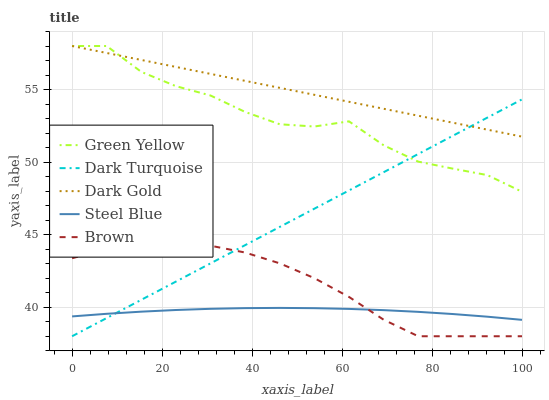Does Steel Blue have the minimum area under the curve?
Answer yes or no. Yes. Does Dark Gold have the maximum area under the curve?
Answer yes or no. Yes. Does Green Yellow have the minimum area under the curve?
Answer yes or no. No. Does Green Yellow have the maximum area under the curve?
Answer yes or no. No. Is Dark Gold the smoothest?
Answer yes or no. Yes. Is Green Yellow the roughest?
Answer yes or no. Yes. Is Steel Blue the smoothest?
Answer yes or no. No. Is Steel Blue the roughest?
Answer yes or no. No. Does Green Yellow have the lowest value?
Answer yes or no. No. Does Steel Blue have the highest value?
Answer yes or no. No. Is Brown less than Green Yellow?
Answer yes or no. Yes. Is Green Yellow greater than Brown?
Answer yes or no. Yes. Does Brown intersect Green Yellow?
Answer yes or no. No. 